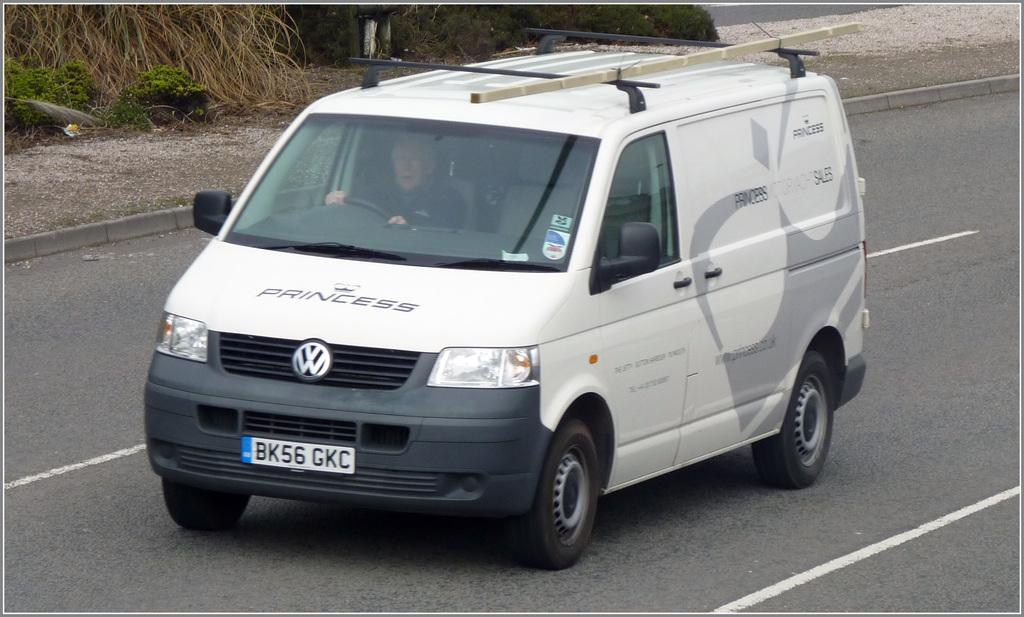<image>
Present a compact description of the photo's key features. A white VW van has the word "princess" on it. 